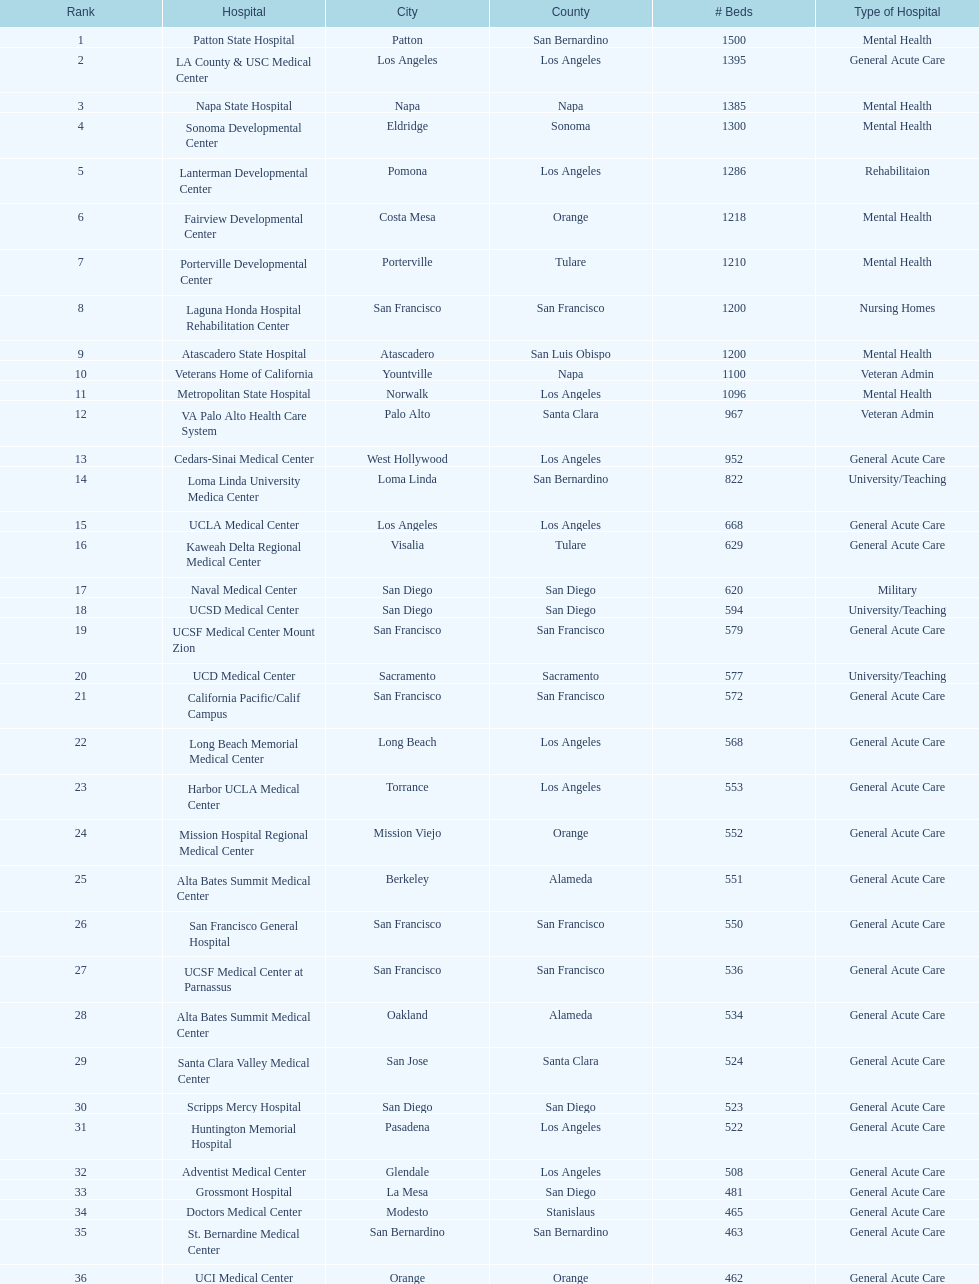Could you parse the entire table? {'header': ['Rank', 'Hospital', 'City', 'County', '# Beds', 'Type of Hospital'], 'rows': [['1', 'Patton State Hospital', 'Patton', 'San Bernardino', '1500', 'Mental Health'], ['2', 'LA County & USC Medical Center', 'Los Angeles', 'Los Angeles', '1395', 'General Acute Care'], ['3', 'Napa State Hospital', 'Napa', 'Napa', '1385', 'Mental Health'], ['4', 'Sonoma Developmental Center', 'Eldridge', 'Sonoma', '1300', 'Mental Health'], ['5', 'Lanterman Developmental Center', 'Pomona', 'Los Angeles', '1286', 'Rehabilitaion'], ['6', 'Fairview Developmental Center', 'Costa Mesa', 'Orange', '1218', 'Mental Health'], ['7', 'Porterville Developmental Center', 'Porterville', 'Tulare', '1210', 'Mental Health'], ['8', 'Laguna Honda Hospital Rehabilitation Center', 'San Francisco', 'San Francisco', '1200', 'Nursing Homes'], ['9', 'Atascadero State Hospital', 'Atascadero', 'San Luis Obispo', '1200', 'Mental Health'], ['10', 'Veterans Home of California', 'Yountville', 'Napa', '1100', 'Veteran Admin'], ['11', 'Metropolitan State Hospital', 'Norwalk', 'Los Angeles', '1096', 'Mental Health'], ['12', 'VA Palo Alto Health Care System', 'Palo Alto', 'Santa Clara', '967', 'Veteran Admin'], ['13', 'Cedars-Sinai Medical Center', 'West Hollywood', 'Los Angeles', '952', 'General Acute Care'], ['14', 'Loma Linda University Medica Center', 'Loma Linda', 'San Bernardino', '822', 'University/Teaching'], ['15', 'UCLA Medical Center', 'Los Angeles', 'Los Angeles', '668', 'General Acute Care'], ['16', 'Kaweah Delta Regional Medical Center', 'Visalia', 'Tulare', '629', 'General Acute Care'], ['17', 'Naval Medical Center', 'San Diego', 'San Diego', '620', 'Military'], ['18', 'UCSD Medical Center', 'San Diego', 'San Diego', '594', 'University/Teaching'], ['19', 'UCSF Medical Center Mount Zion', 'San Francisco', 'San Francisco', '579', 'General Acute Care'], ['20', 'UCD Medical Center', 'Sacramento', 'Sacramento', '577', 'University/Teaching'], ['21', 'California Pacific/Calif Campus', 'San Francisco', 'San Francisco', '572', 'General Acute Care'], ['22', 'Long Beach Memorial Medical Center', 'Long Beach', 'Los Angeles', '568', 'General Acute Care'], ['23', 'Harbor UCLA Medical Center', 'Torrance', 'Los Angeles', '553', 'General Acute Care'], ['24', 'Mission Hospital Regional Medical Center', 'Mission Viejo', 'Orange', '552', 'General Acute Care'], ['25', 'Alta Bates Summit Medical Center', 'Berkeley', 'Alameda', '551', 'General Acute Care'], ['26', 'San Francisco General Hospital', 'San Francisco', 'San Francisco', '550', 'General Acute Care'], ['27', 'UCSF Medical Center at Parnassus', 'San Francisco', 'San Francisco', '536', 'General Acute Care'], ['28', 'Alta Bates Summit Medical Center', 'Oakland', 'Alameda', '534', 'General Acute Care'], ['29', 'Santa Clara Valley Medical Center', 'San Jose', 'Santa Clara', '524', 'General Acute Care'], ['30', 'Scripps Mercy Hospital', 'San Diego', 'San Diego', '523', 'General Acute Care'], ['31', 'Huntington Memorial Hospital', 'Pasadena', 'Los Angeles', '522', 'General Acute Care'], ['32', 'Adventist Medical Center', 'Glendale', 'Los Angeles', '508', 'General Acute Care'], ['33', 'Grossmont Hospital', 'La Mesa', 'San Diego', '481', 'General Acute Care'], ['34', 'Doctors Medical Center', 'Modesto', 'Stanislaus', '465', 'General Acute Care'], ['35', 'St. Bernardine Medical Center', 'San Bernardino', 'San Bernardino', '463', 'General Acute Care'], ['36', 'UCI Medical Center', 'Orange', 'Orange', '462', 'General Acute Care'], ['37', 'Stanford Medical Center', 'Stanford', 'Santa Clara', '460', 'General Acute Care'], ['38', 'Community Regional Medical Center', 'Fresno', 'Fresno', '457', 'General Acute Care'], ['39', 'Methodist Hospital', 'Arcadia', 'Los Angeles', '455', 'General Acute Care'], ['40', 'Providence St. Joseph Medical Center', 'Burbank', 'Los Angeles', '455', 'General Acute Care'], ['41', 'Hoag Memorial Hospital', 'Newport Beach', 'Orange', '450', 'General Acute Care'], ['42', 'Agnews Developmental Center', 'San Jose', 'Santa Clara', '450', 'Mental Health'], ['43', 'Jewish Home', 'San Francisco', 'San Francisco', '450', 'Nursing Homes'], ['44', 'St. Joseph Hospital Orange', 'Orange', 'Orange', '448', 'General Acute Care'], ['45', 'Presbyterian Intercommunity', 'Whittier', 'Los Angeles', '441', 'General Acute Care'], ['46', 'Kaiser Permanente Medical Center', 'Fontana', 'San Bernardino', '440', 'General Acute Care'], ['47', 'Kaiser Permanente Medical Center', 'Los Angeles', 'Los Angeles', '439', 'General Acute Care'], ['48', 'Pomona Valley Hospital Medical Center', 'Pomona', 'Los Angeles', '436', 'General Acute Care'], ['49', 'Sutter General Medical Center', 'Sacramento', 'Sacramento', '432', 'General Acute Care'], ['50', 'St. Mary Medical Center', 'San Francisco', 'San Francisco', '430', 'General Acute Care'], ['50', 'Good Samaritan Hospital', 'San Jose', 'Santa Clara', '429', 'General Acute Care']]} Is the number of mental health care beds in patton state hospital in patton, san bernardino county higher than those in atascadero state hospital in atascadero, san luis obispo county? Yes. 